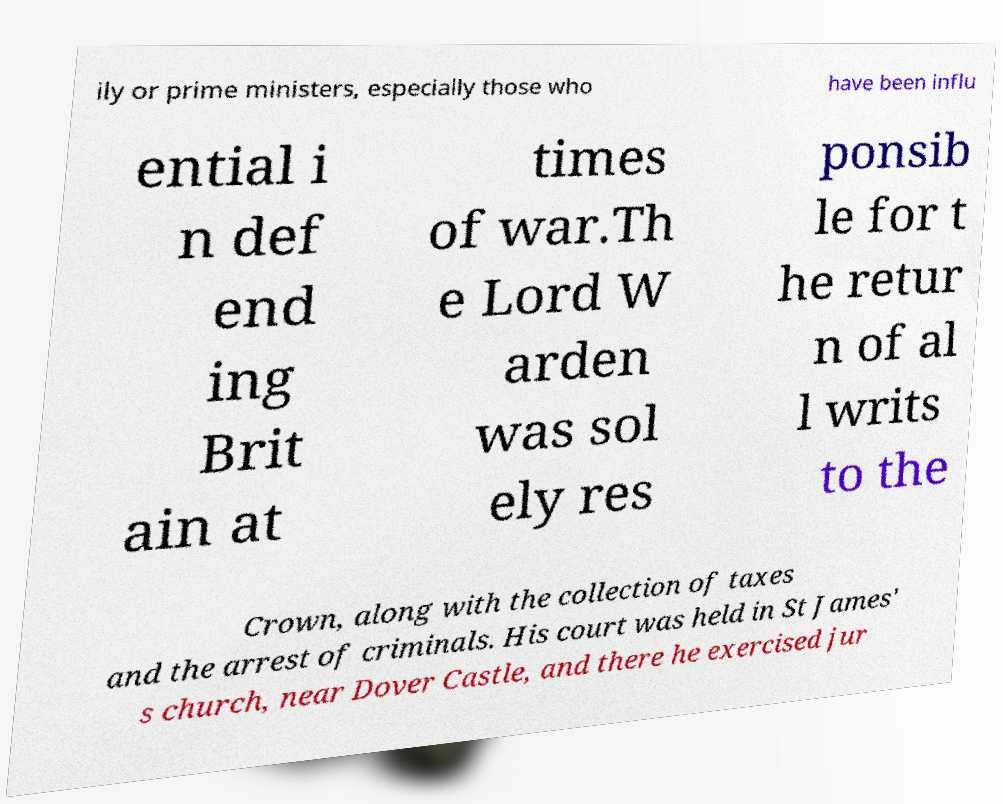Please identify and transcribe the text found in this image. ily or prime ministers, especially those who have been influ ential i n def end ing Brit ain at times of war.Th e Lord W arden was sol ely res ponsib le for t he retur n of al l writs to the Crown, along with the collection of taxes and the arrest of criminals. His court was held in St James' s church, near Dover Castle, and there he exercised jur 